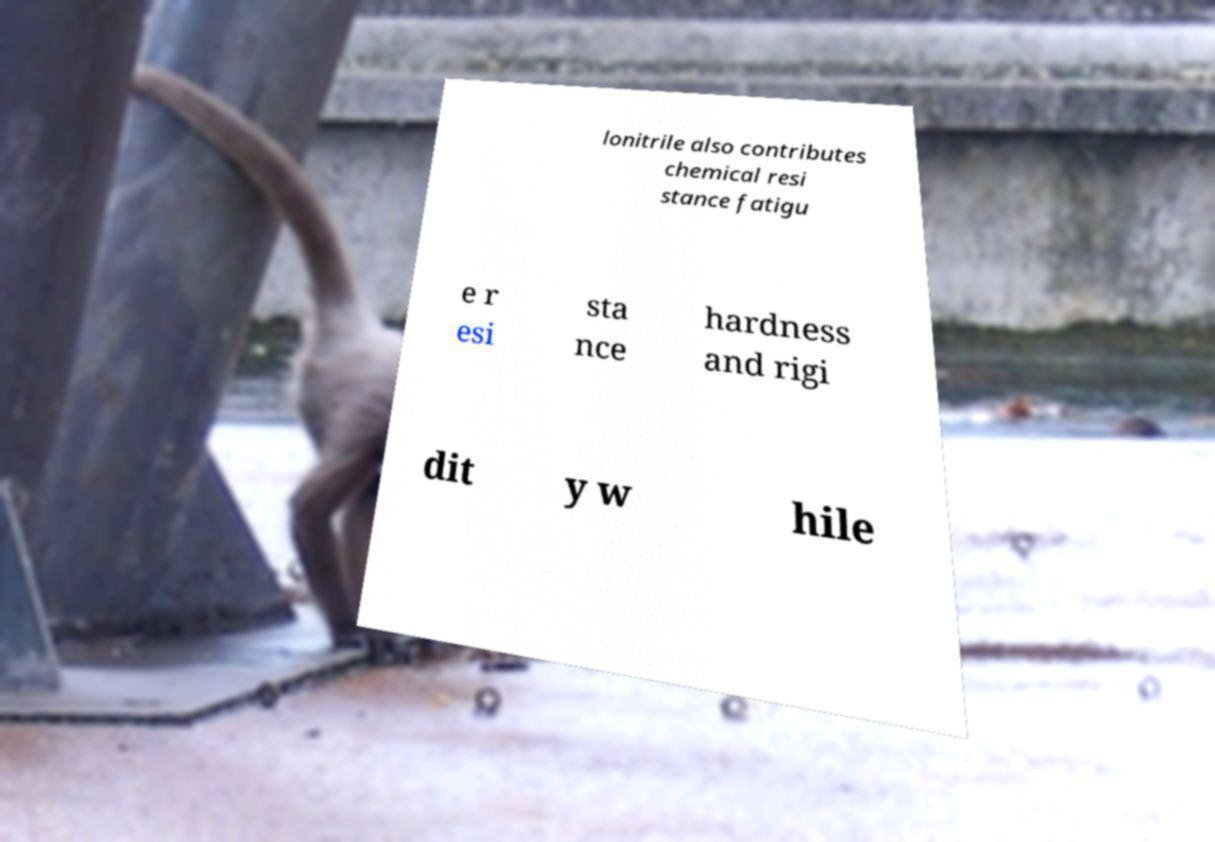Could you assist in decoding the text presented in this image and type it out clearly? lonitrile also contributes chemical resi stance fatigu e r esi sta nce hardness and rigi dit y w hile 